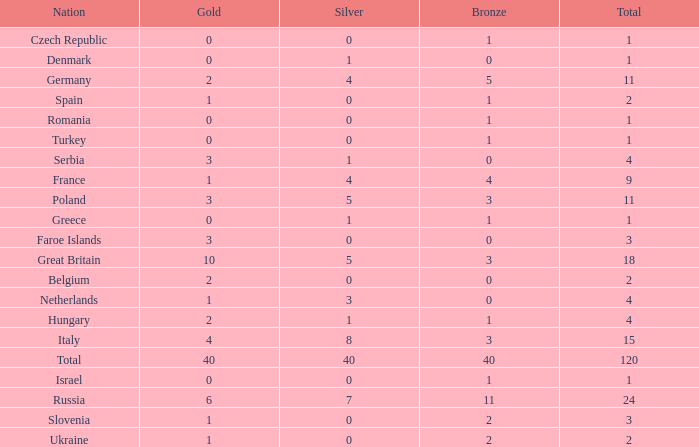What Nation has a Gold entry that is greater than 0, a Total that is greater than 2, a Silver entry that is larger than 1, and 0 Bronze? Netherlands. 